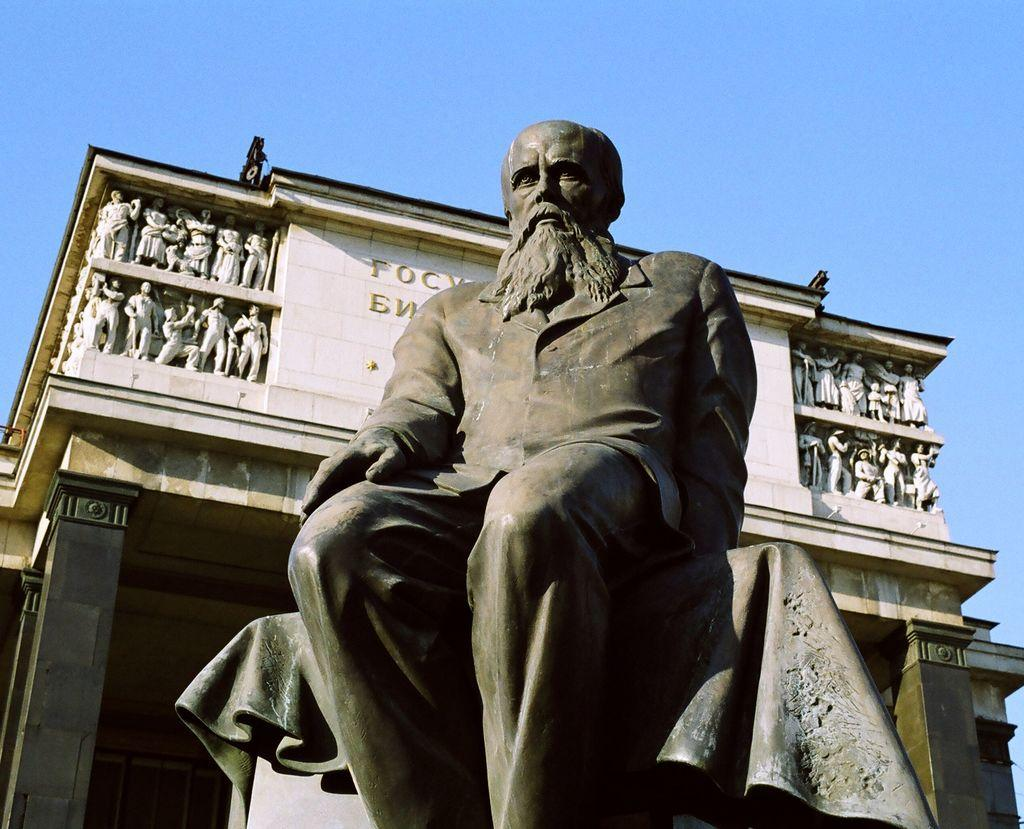What is the main subject in the image? There is a statue in the image. What can be seen behind the statue? There is a building behind the statue. Are there any additional statues in the image? Yes, the building has statues on it. What else is present on the building? There is text on the building. What is visible in the background of the image? The sky is visible in the background of the image. What type of cracker is being used to teach the beginner in the image? There is no cracker or beginner present in the image. 